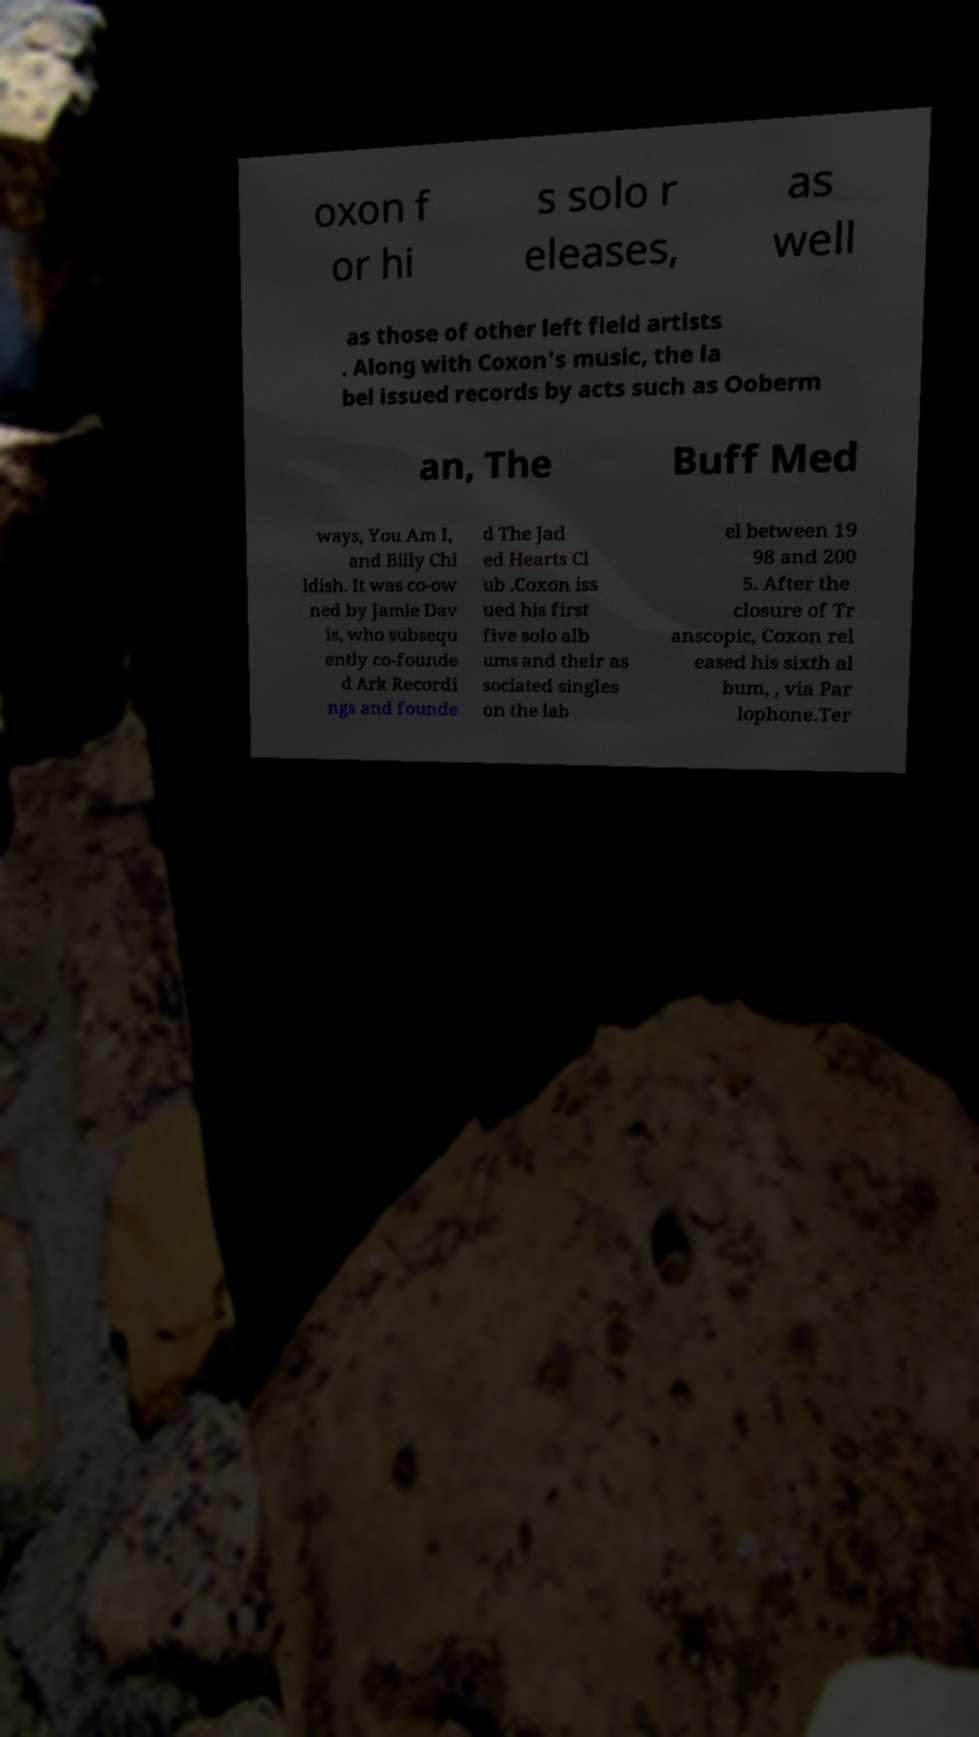There's text embedded in this image that I need extracted. Can you transcribe it verbatim? oxon f or hi s solo r eleases, as well as those of other left field artists . Along with Coxon's music, the la bel issued records by acts such as Ooberm an, The Buff Med ways, You Am I, and Billy Chi ldish. It was co-ow ned by Jamie Dav is, who subsequ ently co-founde d Ark Recordi ngs and founde d The Jad ed Hearts Cl ub .Coxon iss ued his first five solo alb ums and their as sociated singles on the lab el between 19 98 and 200 5. After the closure of Tr anscopic, Coxon rel eased his sixth al bum, , via Par lophone.Ter 